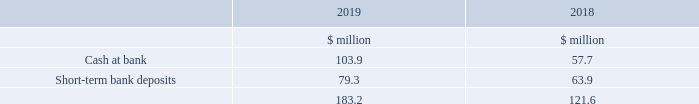22. Cash and cash equivalents
Cash at bank earns interest at floating interest rates. Of the total cash and cash equivalents balance, $79.3 million (2018 $63.9 million) is callable at notice of three months or less at the date of investment.
Short-term bank deposits are made for varying periods of between one day and three months depending on the cash requirements of the Group and earn interest at the short-term deposit rates appropriate for the term of the deposit and currency.
At the end of 2019, the currency split of cash and cash equivalents was US Dollar 78 per cent (2018 83 per cent), Sterling 11 per cent (2018 8 per cent) and other currencies 11 per cent (2018 9 per cent).
For the purposes of the cash flow statement, cash and cash equivalents comprise the above amounts.
What amount of the total cash and cash equivalents balance is callable at notice of three months or less at the date of investment in 2019? $79.3 million. What are short-term bank deposits made for? Varying periods of between one day and three months depending on the cash requirements of the group and earn interest at the short-term deposit rates appropriate for the term of the deposit and currency. What are the items under cash and cash equivalents, for the purposes of the cash flow statement? Cash at bank, short-term bank deposits. In which year was the amount of short-term bank deposits larger? 79.3>63.9
Answer: 2019. What was the change in the cash at bank?
Answer scale should be: million. 103.9-57.7
Answer: 46.2. What was the percentage change in the cash at bank?
Answer scale should be: percent. (103.9-57.7)/57.7
Answer: 80.07. 